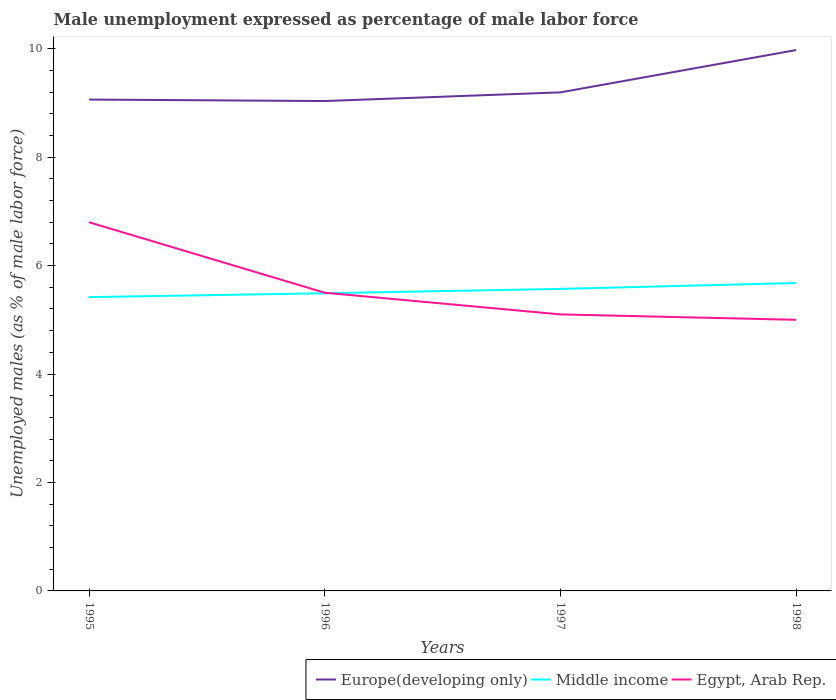How many different coloured lines are there?
Make the answer very short. 3. Does the line corresponding to Middle income intersect with the line corresponding to Egypt, Arab Rep.?
Your response must be concise. Yes. Is the number of lines equal to the number of legend labels?
Your answer should be very brief. Yes. What is the total unemployment in males in in Europe(developing only) in the graph?
Your answer should be compact. -0.13. What is the difference between the highest and the second highest unemployment in males in in Europe(developing only)?
Ensure brevity in your answer.  0.94. What is the difference between the highest and the lowest unemployment in males in in Middle income?
Your answer should be very brief. 2. Is the unemployment in males in in Europe(developing only) strictly greater than the unemployment in males in in Middle income over the years?
Offer a very short reply. No. How many lines are there?
Offer a terse response. 3. How many years are there in the graph?
Ensure brevity in your answer.  4. Does the graph contain any zero values?
Make the answer very short. No. Does the graph contain grids?
Make the answer very short. No. Where does the legend appear in the graph?
Offer a terse response. Bottom right. What is the title of the graph?
Offer a very short reply. Male unemployment expressed as percentage of male labor force. What is the label or title of the X-axis?
Your answer should be very brief. Years. What is the label or title of the Y-axis?
Your response must be concise. Unemployed males (as % of male labor force). What is the Unemployed males (as % of male labor force) of Europe(developing only) in 1995?
Keep it short and to the point. 9.06. What is the Unemployed males (as % of male labor force) of Middle income in 1995?
Your response must be concise. 5.42. What is the Unemployed males (as % of male labor force) of Egypt, Arab Rep. in 1995?
Ensure brevity in your answer.  6.8. What is the Unemployed males (as % of male labor force) in Europe(developing only) in 1996?
Provide a succinct answer. 9.03. What is the Unemployed males (as % of male labor force) in Middle income in 1996?
Make the answer very short. 5.49. What is the Unemployed males (as % of male labor force) in Egypt, Arab Rep. in 1996?
Your answer should be compact. 5.5. What is the Unemployed males (as % of male labor force) in Europe(developing only) in 1997?
Ensure brevity in your answer.  9.19. What is the Unemployed males (as % of male labor force) in Middle income in 1997?
Make the answer very short. 5.57. What is the Unemployed males (as % of male labor force) of Egypt, Arab Rep. in 1997?
Provide a short and direct response. 5.1. What is the Unemployed males (as % of male labor force) of Europe(developing only) in 1998?
Offer a very short reply. 9.98. What is the Unemployed males (as % of male labor force) of Middle income in 1998?
Make the answer very short. 5.68. What is the Unemployed males (as % of male labor force) in Egypt, Arab Rep. in 1998?
Offer a terse response. 5. Across all years, what is the maximum Unemployed males (as % of male labor force) of Europe(developing only)?
Your answer should be compact. 9.98. Across all years, what is the maximum Unemployed males (as % of male labor force) in Middle income?
Your answer should be very brief. 5.68. Across all years, what is the maximum Unemployed males (as % of male labor force) of Egypt, Arab Rep.?
Ensure brevity in your answer.  6.8. Across all years, what is the minimum Unemployed males (as % of male labor force) of Europe(developing only)?
Offer a very short reply. 9.03. Across all years, what is the minimum Unemployed males (as % of male labor force) in Middle income?
Provide a short and direct response. 5.42. Across all years, what is the minimum Unemployed males (as % of male labor force) of Egypt, Arab Rep.?
Ensure brevity in your answer.  5. What is the total Unemployed males (as % of male labor force) of Europe(developing only) in the graph?
Make the answer very short. 37.27. What is the total Unemployed males (as % of male labor force) in Middle income in the graph?
Provide a succinct answer. 22.16. What is the total Unemployed males (as % of male labor force) of Egypt, Arab Rep. in the graph?
Provide a succinct answer. 22.4. What is the difference between the Unemployed males (as % of male labor force) of Europe(developing only) in 1995 and that in 1996?
Provide a succinct answer. 0.03. What is the difference between the Unemployed males (as % of male labor force) in Middle income in 1995 and that in 1996?
Offer a very short reply. -0.07. What is the difference between the Unemployed males (as % of male labor force) in Egypt, Arab Rep. in 1995 and that in 1996?
Make the answer very short. 1.3. What is the difference between the Unemployed males (as % of male labor force) in Europe(developing only) in 1995 and that in 1997?
Provide a succinct answer. -0.13. What is the difference between the Unemployed males (as % of male labor force) in Middle income in 1995 and that in 1997?
Your answer should be compact. -0.15. What is the difference between the Unemployed males (as % of male labor force) in Europe(developing only) in 1995 and that in 1998?
Your answer should be very brief. -0.91. What is the difference between the Unemployed males (as % of male labor force) in Middle income in 1995 and that in 1998?
Provide a succinct answer. -0.26. What is the difference between the Unemployed males (as % of male labor force) of Egypt, Arab Rep. in 1995 and that in 1998?
Provide a short and direct response. 1.8. What is the difference between the Unemployed males (as % of male labor force) of Europe(developing only) in 1996 and that in 1997?
Your answer should be very brief. -0.16. What is the difference between the Unemployed males (as % of male labor force) of Middle income in 1996 and that in 1997?
Provide a short and direct response. -0.08. What is the difference between the Unemployed males (as % of male labor force) of Europe(developing only) in 1996 and that in 1998?
Provide a succinct answer. -0.94. What is the difference between the Unemployed males (as % of male labor force) in Middle income in 1996 and that in 1998?
Offer a terse response. -0.19. What is the difference between the Unemployed males (as % of male labor force) of Egypt, Arab Rep. in 1996 and that in 1998?
Give a very brief answer. 0.5. What is the difference between the Unemployed males (as % of male labor force) in Europe(developing only) in 1997 and that in 1998?
Your response must be concise. -0.78. What is the difference between the Unemployed males (as % of male labor force) of Middle income in 1997 and that in 1998?
Your response must be concise. -0.11. What is the difference between the Unemployed males (as % of male labor force) of Egypt, Arab Rep. in 1997 and that in 1998?
Your answer should be compact. 0.1. What is the difference between the Unemployed males (as % of male labor force) in Europe(developing only) in 1995 and the Unemployed males (as % of male labor force) in Middle income in 1996?
Provide a succinct answer. 3.57. What is the difference between the Unemployed males (as % of male labor force) of Europe(developing only) in 1995 and the Unemployed males (as % of male labor force) of Egypt, Arab Rep. in 1996?
Provide a short and direct response. 3.56. What is the difference between the Unemployed males (as % of male labor force) of Middle income in 1995 and the Unemployed males (as % of male labor force) of Egypt, Arab Rep. in 1996?
Your answer should be very brief. -0.08. What is the difference between the Unemployed males (as % of male labor force) in Europe(developing only) in 1995 and the Unemployed males (as % of male labor force) in Middle income in 1997?
Make the answer very short. 3.49. What is the difference between the Unemployed males (as % of male labor force) of Europe(developing only) in 1995 and the Unemployed males (as % of male labor force) of Egypt, Arab Rep. in 1997?
Offer a terse response. 3.96. What is the difference between the Unemployed males (as % of male labor force) of Middle income in 1995 and the Unemployed males (as % of male labor force) of Egypt, Arab Rep. in 1997?
Offer a terse response. 0.32. What is the difference between the Unemployed males (as % of male labor force) of Europe(developing only) in 1995 and the Unemployed males (as % of male labor force) of Middle income in 1998?
Your answer should be very brief. 3.38. What is the difference between the Unemployed males (as % of male labor force) in Europe(developing only) in 1995 and the Unemployed males (as % of male labor force) in Egypt, Arab Rep. in 1998?
Your response must be concise. 4.06. What is the difference between the Unemployed males (as % of male labor force) of Middle income in 1995 and the Unemployed males (as % of male labor force) of Egypt, Arab Rep. in 1998?
Make the answer very short. 0.42. What is the difference between the Unemployed males (as % of male labor force) in Europe(developing only) in 1996 and the Unemployed males (as % of male labor force) in Middle income in 1997?
Keep it short and to the point. 3.46. What is the difference between the Unemployed males (as % of male labor force) in Europe(developing only) in 1996 and the Unemployed males (as % of male labor force) in Egypt, Arab Rep. in 1997?
Your response must be concise. 3.93. What is the difference between the Unemployed males (as % of male labor force) in Middle income in 1996 and the Unemployed males (as % of male labor force) in Egypt, Arab Rep. in 1997?
Keep it short and to the point. 0.39. What is the difference between the Unemployed males (as % of male labor force) of Europe(developing only) in 1996 and the Unemployed males (as % of male labor force) of Middle income in 1998?
Ensure brevity in your answer.  3.36. What is the difference between the Unemployed males (as % of male labor force) in Europe(developing only) in 1996 and the Unemployed males (as % of male labor force) in Egypt, Arab Rep. in 1998?
Provide a short and direct response. 4.03. What is the difference between the Unemployed males (as % of male labor force) in Middle income in 1996 and the Unemployed males (as % of male labor force) in Egypt, Arab Rep. in 1998?
Ensure brevity in your answer.  0.49. What is the difference between the Unemployed males (as % of male labor force) in Europe(developing only) in 1997 and the Unemployed males (as % of male labor force) in Middle income in 1998?
Provide a short and direct response. 3.52. What is the difference between the Unemployed males (as % of male labor force) in Europe(developing only) in 1997 and the Unemployed males (as % of male labor force) in Egypt, Arab Rep. in 1998?
Your answer should be very brief. 4.2. What is the difference between the Unemployed males (as % of male labor force) in Middle income in 1997 and the Unemployed males (as % of male labor force) in Egypt, Arab Rep. in 1998?
Your answer should be very brief. 0.57. What is the average Unemployed males (as % of male labor force) in Europe(developing only) per year?
Your answer should be compact. 9.32. What is the average Unemployed males (as % of male labor force) in Middle income per year?
Make the answer very short. 5.54. What is the average Unemployed males (as % of male labor force) in Egypt, Arab Rep. per year?
Give a very brief answer. 5.6. In the year 1995, what is the difference between the Unemployed males (as % of male labor force) of Europe(developing only) and Unemployed males (as % of male labor force) of Middle income?
Offer a very short reply. 3.64. In the year 1995, what is the difference between the Unemployed males (as % of male labor force) of Europe(developing only) and Unemployed males (as % of male labor force) of Egypt, Arab Rep.?
Provide a succinct answer. 2.26. In the year 1995, what is the difference between the Unemployed males (as % of male labor force) of Middle income and Unemployed males (as % of male labor force) of Egypt, Arab Rep.?
Offer a very short reply. -1.38. In the year 1996, what is the difference between the Unemployed males (as % of male labor force) in Europe(developing only) and Unemployed males (as % of male labor force) in Middle income?
Offer a very short reply. 3.54. In the year 1996, what is the difference between the Unemployed males (as % of male labor force) in Europe(developing only) and Unemployed males (as % of male labor force) in Egypt, Arab Rep.?
Provide a short and direct response. 3.53. In the year 1996, what is the difference between the Unemployed males (as % of male labor force) of Middle income and Unemployed males (as % of male labor force) of Egypt, Arab Rep.?
Your answer should be very brief. -0.01. In the year 1997, what is the difference between the Unemployed males (as % of male labor force) of Europe(developing only) and Unemployed males (as % of male labor force) of Middle income?
Provide a succinct answer. 3.62. In the year 1997, what is the difference between the Unemployed males (as % of male labor force) in Europe(developing only) and Unemployed males (as % of male labor force) in Egypt, Arab Rep.?
Provide a short and direct response. 4.09. In the year 1997, what is the difference between the Unemployed males (as % of male labor force) in Middle income and Unemployed males (as % of male labor force) in Egypt, Arab Rep.?
Give a very brief answer. 0.47. In the year 1998, what is the difference between the Unemployed males (as % of male labor force) of Europe(developing only) and Unemployed males (as % of male labor force) of Middle income?
Your answer should be compact. 4.3. In the year 1998, what is the difference between the Unemployed males (as % of male labor force) in Europe(developing only) and Unemployed males (as % of male labor force) in Egypt, Arab Rep.?
Your answer should be very brief. 4.98. In the year 1998, what is the difference between the Unemployed males (as % of male labor force) in Middle income and Unemployed males (as % of male labor force) in Egypt, Arab Rep.?
Make the answer very short. 0.68. What is the ratio of the Unemployed males (as % of male labor force) in Europe(developing only) in 1995 to that in 1996?
Your response must be concise. 1. What is the ratio of the Unemployed males (as % of male labor force) in Middle income in 1995 to that in 1996?
Keep it short and to the point. 0.99. What is the ratio of the Unemployed males (as % of male labor force) in Egypt, Arab Rep. in 1995 to that in 1996?
Keep it short and to the point. 1.24. What is the ratio of the Unemployed males (as % of male labor force) of Europe(developing only) in 1995 to that in 1997?
Offer a very short reply. 0.99. What is the ratio of the Unemployed males (as % of male labor force) in Middle income in 1995 to that in 1997?
Provide a short and direct response. 0.97. What is the ratio of the Unemployed males (as % of male labor force) of Europe(developing only) in 1995 to that in 1998?
Offer a terse response. 0.91. What is the ratio of the Unemployed males (as % of male labor force) of Middle income in 1995 to that in 1998?
Your answer should be compact. 0.95. What is the ratio of the Unemployed males (as % of male labor force) in Egypt, Arab Rep. in 1995 to that in 1998?
Give a very brief answer. 1.36. What is the ratio of the Unemployed males (as % of male labor force) of Europe(developing only) in 1996 to that in 1997?
Your answer should be compact. 0.98. What is the ratio of the Unemployed males (as % of male labor force) of Middle income in 1996 to that in 1997?
Your response must be concise. 0.99. What is the ratio of the Unemployed males (as % of male labor force) of Egypt, Arab Rep. in 1996 to that in 1997?
Ensure brevity in your answer.  1.08. What is the ratio of the Unemployed males (as % of male labor force) of Europe(developing only) in 1996 to that in 1998?
Offer a very short reply. 0.91. What is the ratio of the Unemployed males (as % of male labor force) in Middle income in 1996 to that in 1998?
Your answer should be compact. 0.97. What is the ratio of the Unemployed males (as % of male labor force) of Europe(developing only) in 1997 to that in 1998?
Your answer should be compact. 0.92. What is the ratio of the Unemployed males (as % of male labor force) in Middle income in 1997 to that in 1998?
Provide a short and direct response. 0.98. What is the difference between the highest and the second highest Unemployed males (as % of male labor force) in Europe(developing only)?
Keep it short and to the point. 0.78. What is the difference between the highest and the second highest Unemployed males (as % of male labor force) of Middle income?
Provide a succinct answer. 0.11. What is the difference between the highest and the lowest Unemployed males (as % of male labor force) in Europe(developing only)?
Offer a very short reply. 0.94. What is the difference between the highest and the lowest Unemployed males (as % of male labor force) in Middle income?
Ensure brevity in your answer.  0.26. What is the difference between the highest and the lowest Unemployed males (as % of male labor force) of Egypt, Arab Rep.?
Your response must be concise. 1.8. 